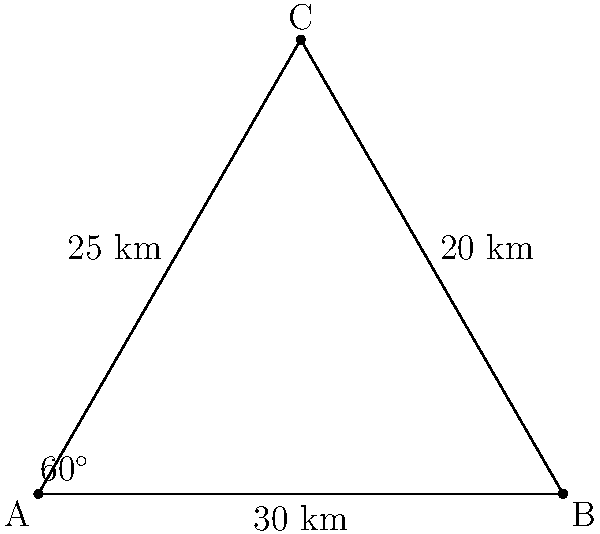Three weather monitoring stations A, B, and C form a triangle as shown in the diagram. Station A is 30 km from B, 25 km from C, and the angle between these distances is 60°. A severe thunderstorm is detected 20 km from station B and 25 km from station C. Using triangulation, determine the distance of the thunderstorm from station A. Let's approach this step-by-step:

1) First, we need to find the coordinates of the three stations. We can set A at (0,0), B at (30,0), and calculate C's position.

2) To find C's coordinates, we use trigonometry:
   $C_x = 25 \cos(60°) = 12.5$
   $C_y = 25 \sin(60°) = 21.65$

3) Now, we have a new triangle formed by the thunderstorm (let's call it T) and stations B and C. We know two sides of this triangle: BT = 20 km and CT = 25 km.

4) To find the angle at C in this new triangle, we can use the law of cosines:
   $\cos(\angle BCT) = \frac{BC^2 + CT^2 - BT^2}{2(BC)(CT)}$

5) We can calculate BC using the distance formula:
   $BC = \sqrt{(30-12.5)^2 + (0-21.65)^2} = 25$

6) Now we can solve for $\angle BCT$:
   $\cos(\angle BCT) = \frac{25^2 + 25^2 - 20^2}{2(25)(25)} = 0.84$
   $\angle BCT = \arccos(0.84) = 32.86°$

7) The angle between AC and CT is $60° - 32.86° = 27.14°$

8) Finally, we can use the law of cosines again to find AT:
   $AT^2 = AC^2 + CT^2 - 2(AC)(CT)\cos(27.14°)$
   $AT^2 = 25^2 + 25^2 - 2(25)(25)\cos(27.14°)$
   $AT = \sqrt{1250 - 1118.53} = 15.72$

Therefore, the thunderstorm is approximately 15.72 km from station A.
Answer: 15.72 km 